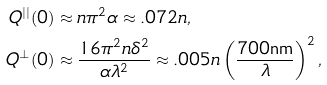<formula> <loc_0><loc_0><loc_500><loc_500>Q ^ { | | } ( 0 ) & \approx n \pi ^ { 2 } \alpha \approx . 0 7 2 n , \\ Q ^ { \perp } ( 0 ) & \approx \frac { 1 6 \pi ^ { 2 } n \delta ^ { 2 } } { \alpha \lambda ^ { 2 } } \approx . 0 0 5 n \left ( \frac { 7 0 0 \text {nm} } { \lambda } \right ) ^ { 2 } ,</formula> 